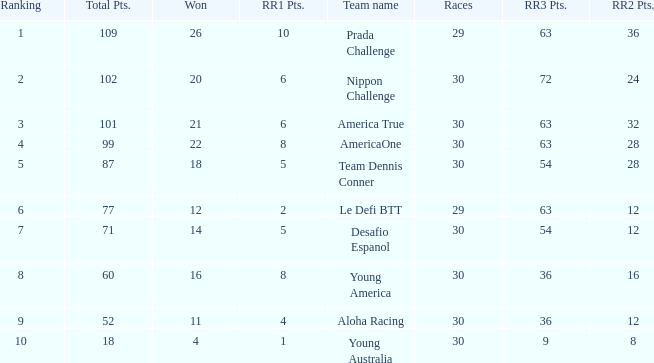Name the ranking for rr2 pts being 8 10.0. Could you help me parse every detail presented in this table? {'header': ['Ranking', 'Total Pts.', 'Won', 'RR1 Pts.', 'Team name', 'Races', 'RR3 Pts.', 'RR2 Pts.'], 'rows': [['1', '109', '26', '10', 'Prada Challenge', '29', '63', '36'], ['2', '102', '20', '6', 'Nippon Challenge', '30', '72', '24'], ['3', '101', '21', '6', 'America True', '30', '63', '32'], ['4', '99', '22', '8', 'AmericaOne', '30', '63', '28'], ['5', '87', '18', '5', 'Team Dennis Conner', '30', '54', '28'], ['6', '77', '12', '2', 'Le Defi BTT', '29', '63', '12'], ['7', '71', '14', '5', 'Desafio Espanol', '30', '54', '12'], ['8', '60', '16', '8', 'Young America', '30', '36', '16'], ['9', '52', '11', '4', 'Aloha Racing', '30', '36', '12'], ['10', '18', '4', '1', 'Young Australia', '30', '9', '8']]} 